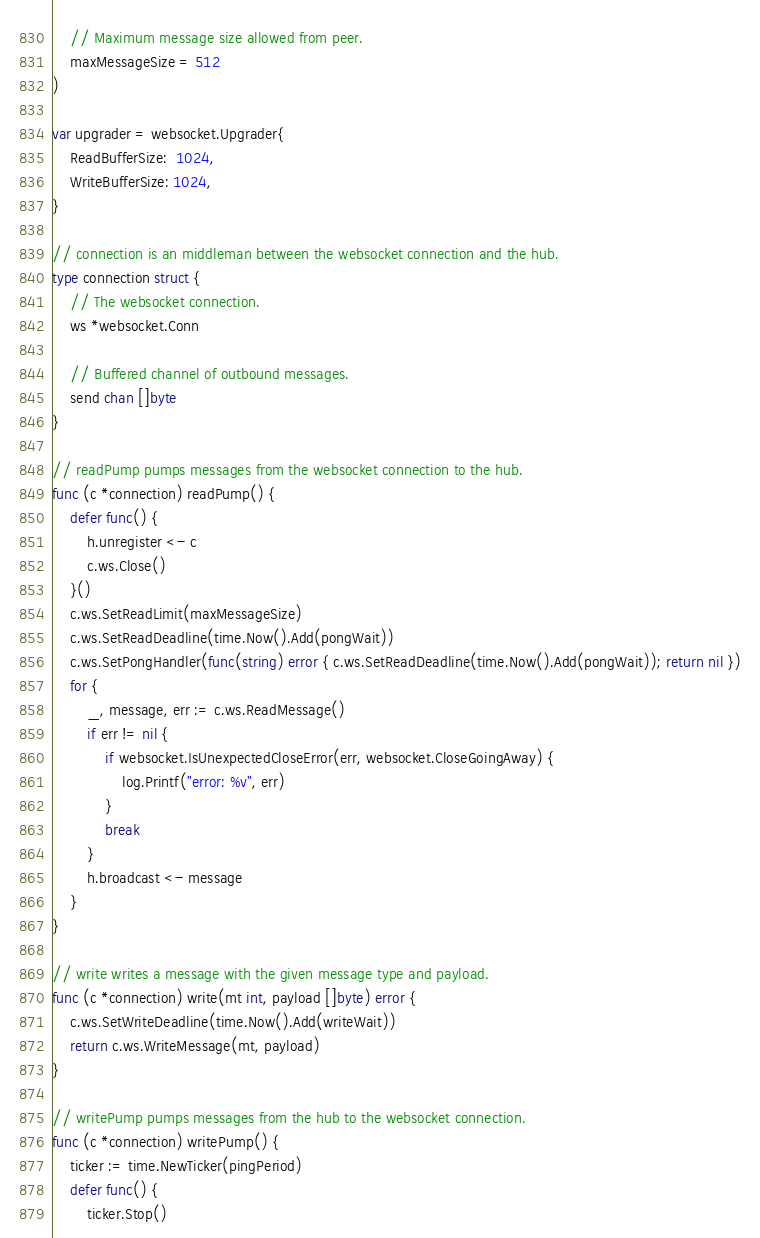Convert code to text. <code><loc_0><loc_0><loc_500><loc_500><_Go_>
	// Maximum message size allowed from peer.
	maxMessageSize = 512
)

var upgrader = websocket.Upgrader{
	ReadBufferSize:  1024,
	WriteBufferSize: 1024,
}

// connection is an middleman between the websocket connection and the hub.
type connection struct {
	// The websocket connection.
	ws *websocket.Conn

	// Buffered channel of outbound messages.
	send chan []byte
}

// readPump pumps messages from the websocket connection to the hub.
func (c *connection) readPump() {
	defer func() {
		h.unregister <- c
		c.ws.Close()
	}()
	c.ws.SetReadLimit(maxMessageSize)
	c.ws.SetReadDeadline(time.Now().Add(pongWait))
	c.ws.SetPongHandler(func(string) error { c.ws.SetReadDeadline(time.Now().Add(pongWait)); return nil })
	for {
		_, message, err := c.ws.ReadMessage()
		if err != nil {
			if websocket.IsUnexpectedCloseError(err, websocket.CloseGoingAway) {
				log.Printf("error: %v", err)
			}
			break
		}
		h.broadcast <- message
	}
}

// write writes a message with the given message type and payload.
func (c *connection) write(mt int, payload []byte) error {
	c.ws.SetWriteDeadline(time.Now().Add(writeWait))
	return c.ws.WriteMessage(mt, payload)
}

// writePump pumps messages from the hub to the websocket connection.
func (c *connection) writePump() {
	ticker := time.NewTicker(pingPeriod)
	defer func() {
		ticker.Stop()</code> 